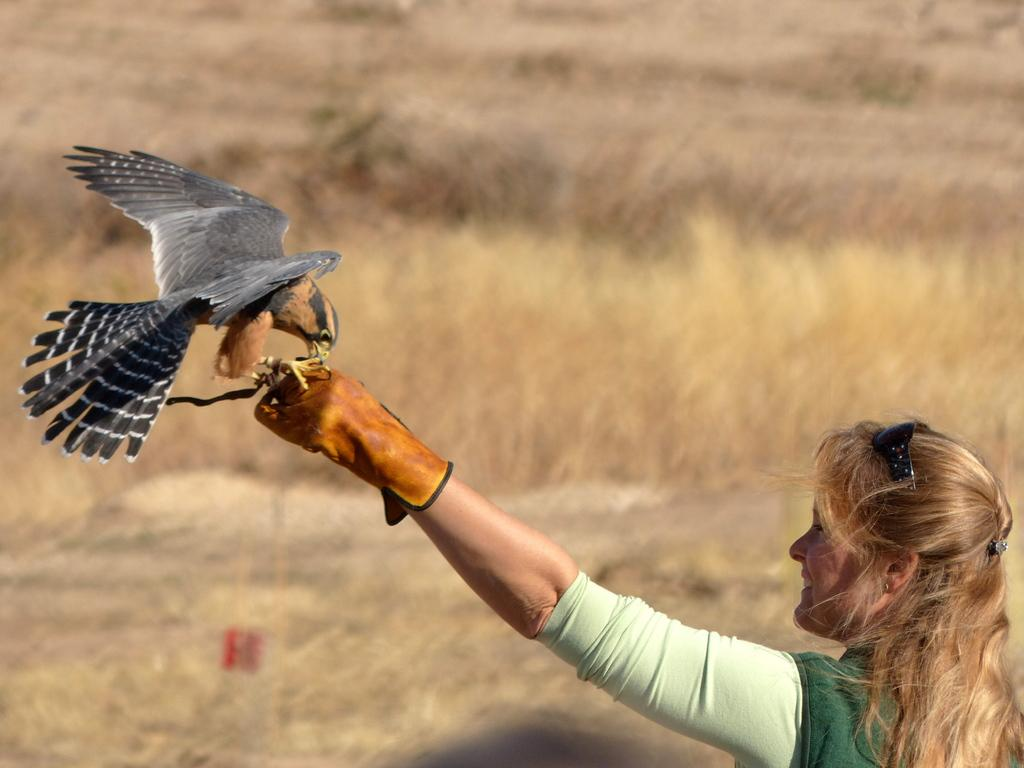Who is the main subject in the foreground of the picture? There is a woman in the foreground of the picture. What is the woman doing with her hand? The woman is stretching out her hand. What is on the woman's hand? There is an eagle on the woman's hand. Can you describe the background of the image? The background of the image is blurred. What type of cord is being used by the woman to control the sail in the image? There is no cord or sail present in the image; it features a woman with an eagle on her hand. 